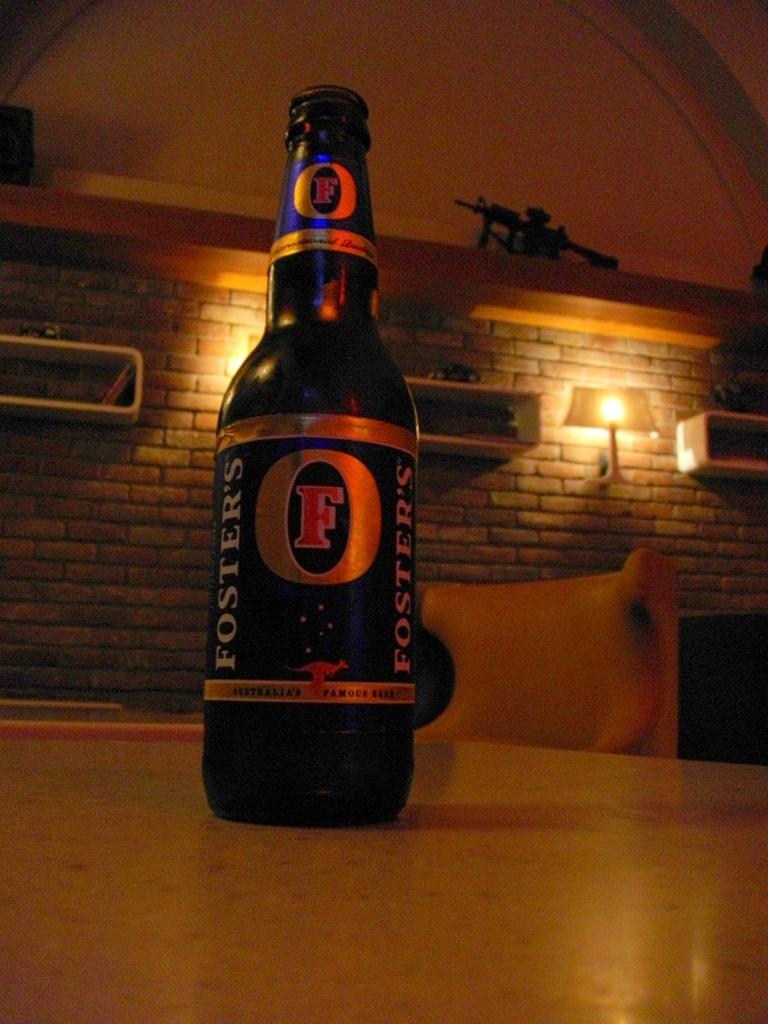What beer is that?
Give a very brief answer. Foster's. 